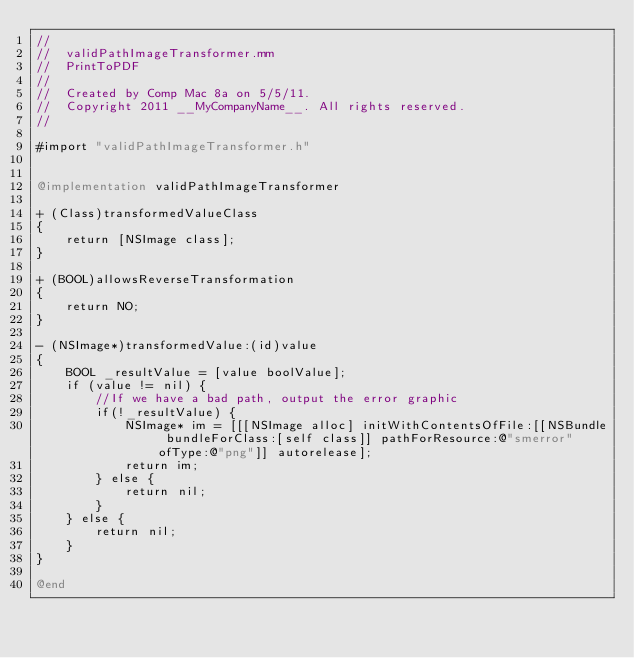<code> <loc_0><loc_0><loc_500><loc_500><_ObjectiveC_>//
//  validPathImageTransformer.mm
//  PrintToPDF
//
//  Created by Comp Mac 8a on 5/5/11.
//  Copyright 2011 __MyCompanyName__. All rights reserved.
//

#import "validPathImageTransformer.h"


@implementation validPathImageTransformer

+ (Class)transformedValueClass
{
	return [NSImage class];
}

+ (BOOL)allowsReverseTransformation
{
	return NO;
}

- (NSImage*)transformedValue:(id)value
{
	BOOL _resultValue = [value boolValue];
	if (value != nil) {
		//If we have a bad path, output the error graphic
		if(!_resultValue) {
			NSImage* im = [[[NSImage alloc] initWithContentsOfFile:[[NSBundle bundleForClass:[self class]] pathForResource:@"smerror" ofType:@"png"]] autorelease];
			return im;
		} else {
			return nil;
		}
	} else {
		return nil;
	}
}

@end
</code> 